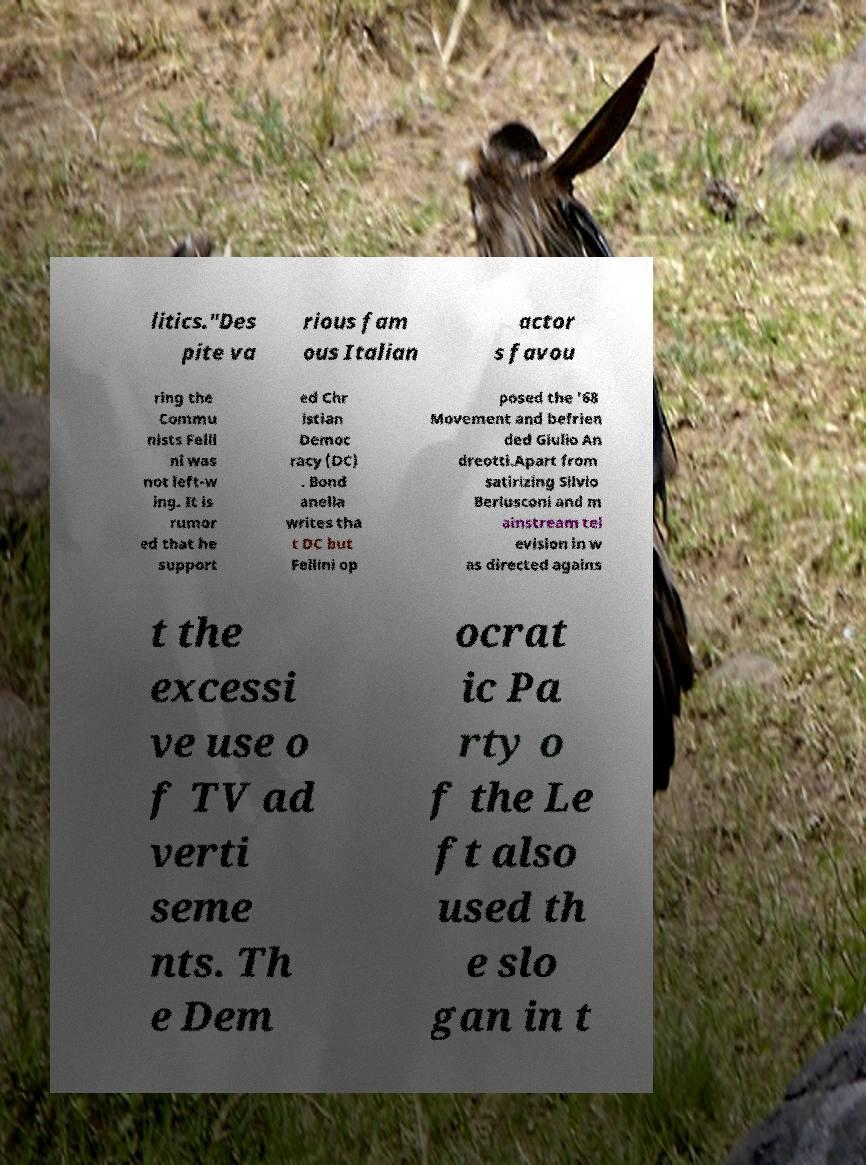What messages or text are displayed in this image? I need them in a readable, typed format. litics."Des pite va rious fam ous Italian actor s favou ring the Commu nists Felli ni was not left-w ing. It is rumor ed that he support ed Chr istian Democ racy (DC) . Bond anella writes tha t DC but Fellini op posed the '68 Movement and befrien ded Giulio An dreotti.Apart from satirizing Silvio Berlusconi and m ainstream tel evision in w as directed agains t the excessi ve use o f TV ad verti seme nts. Th e Dem ocrat ic Pa rty o f the Le ft also used th e slo gan in t 